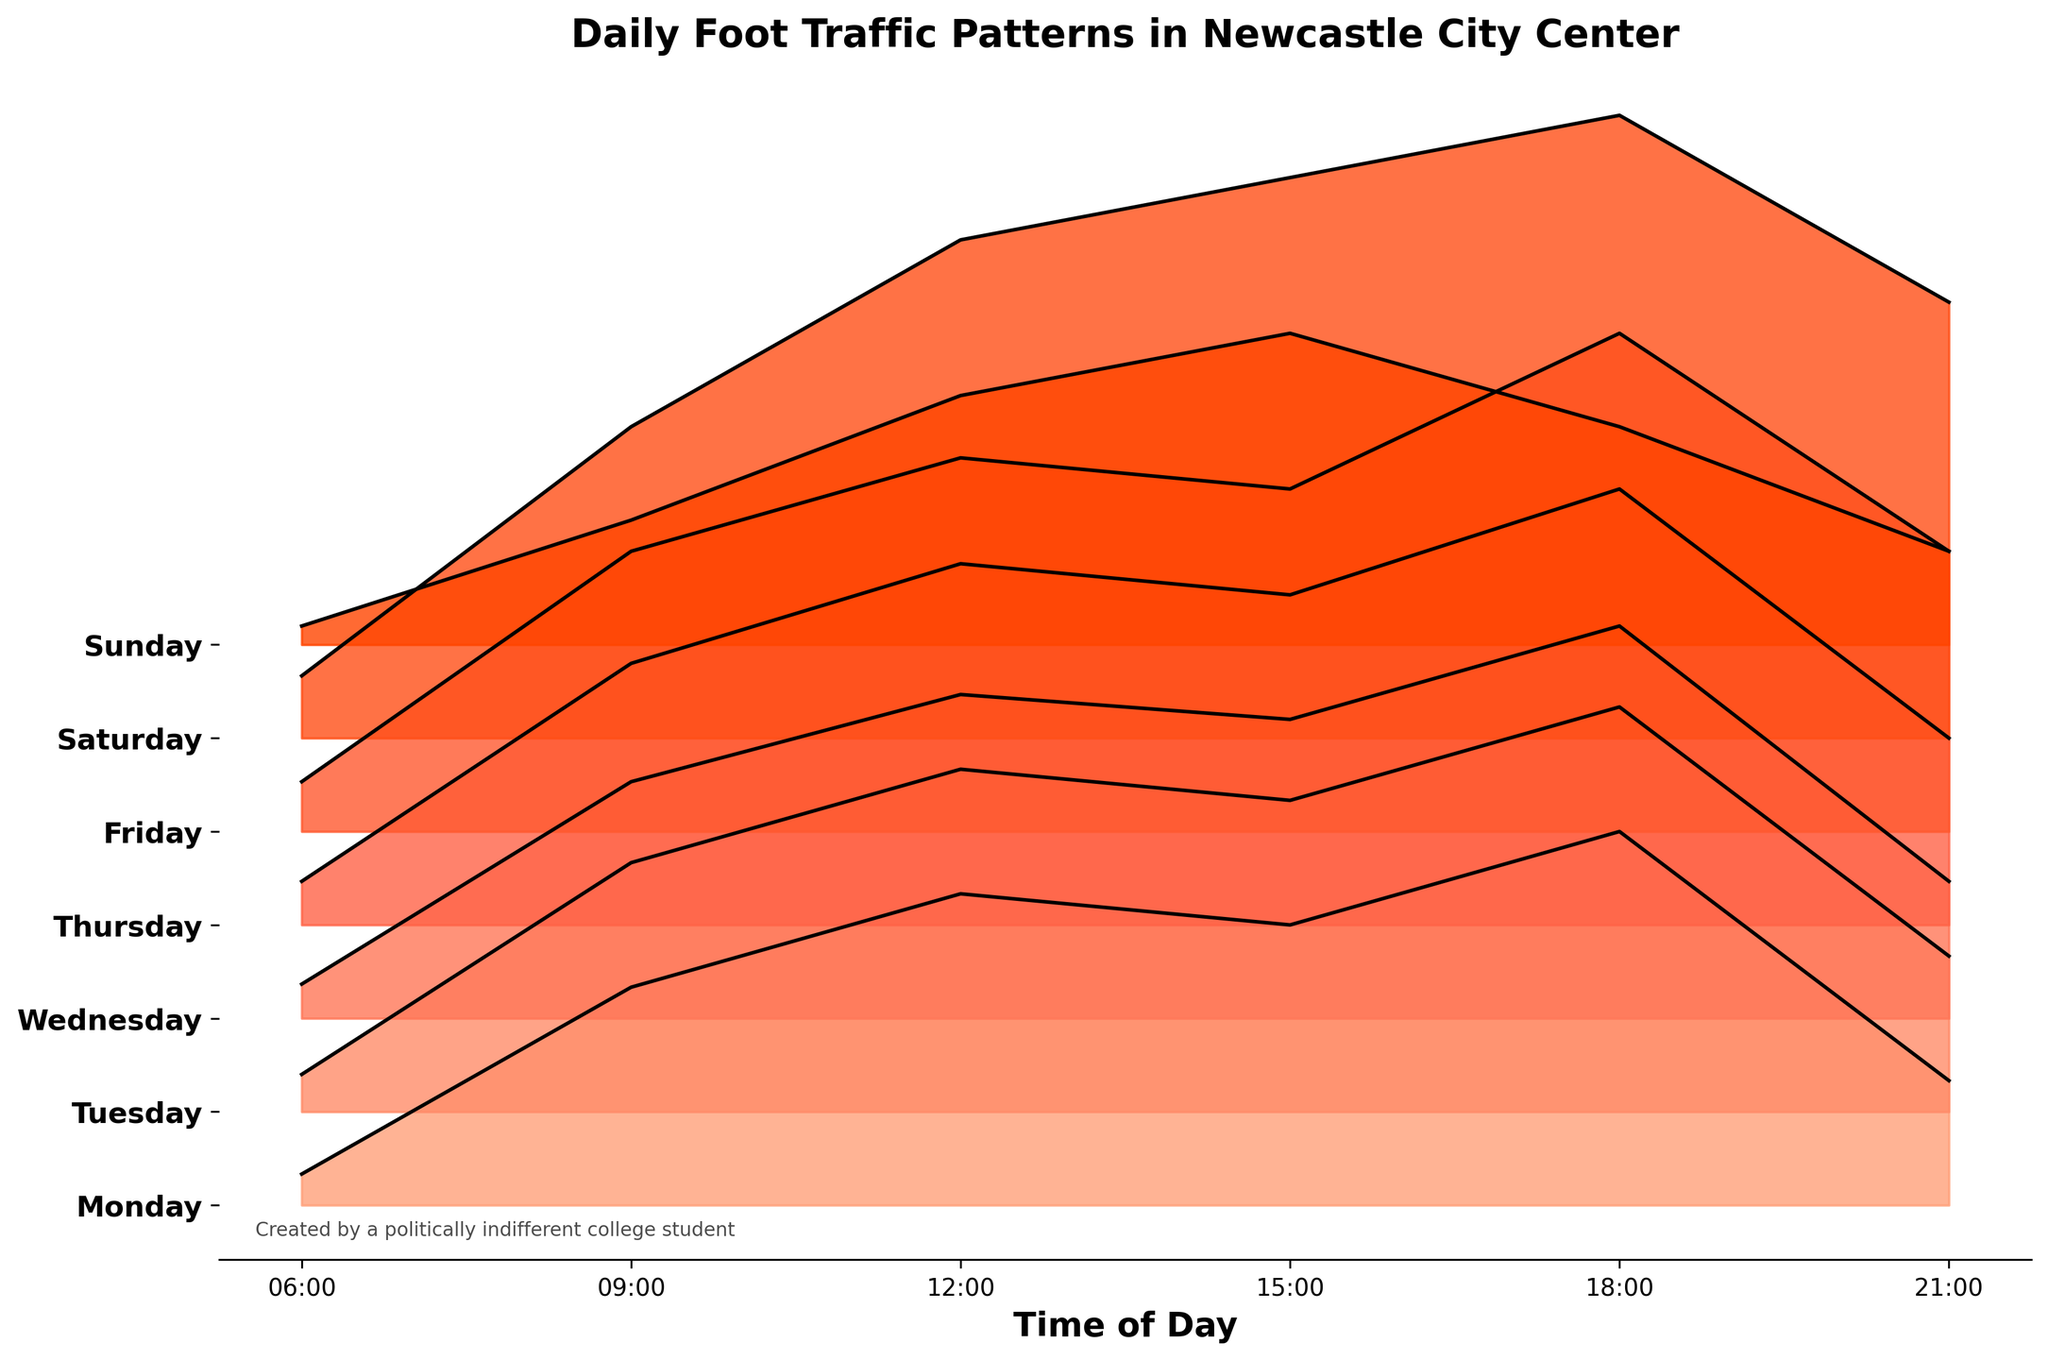What's the peak foot traffic on Saturday? To find the peak foot traffic on Saturday, you look at the data values for Saturday and identify the highest one, which is 1000 at 18:00.
Answer: 1000 Which day has the lowest foot traffic at 6:00? Compare the foot traffic values at 6:00 for each day and find the day with the lowest value, which is Sunday with 30.
Answer: Sunday What times have the highest foot traffic overall in the week? Check the peak values for foot traffic across all days and identify that the highest values occur on Saturday at 18:00 and 15:00 with 1000 and 900 respectively. So, 18:00 has the highest.
Answer: 18:00 How does the foot traffic on Monday at 12:00 compare to the traffic on Tuesday at the same time? Find the foot traffic values for 12:00 on both Monday (500) and Tuesday (550). Since 550 is greater than 500, Tuesday has more foot traffic at that time.
Answer: Tuesday What day generally has the highest foot traffic throughout the day? Summarize the daily patterns and observe that Saturday consistently shows higher foot traffic values compared to the other days, peaking at 1000 at 18:00.
Answer: Saturday Is the foot traffic at 9:00 generally increasing from Monday to Friday? Compare the foot traffic values at 9:00 for Monday (350), Tuesday (400), Wednesday (380), Thursday (420), and Friday (450). Overall, there is a general upward trend.
Answer: Yes For which day is the difference between peak and lowest foot traffic the largest? Find the difference between peak and lowest foot traffic for each day, e.g., Saturday (1000 - 100 = 900) shows the largest difference.
Answer: Saturday Which day has the most consistent foot traffic? Examine the range of foot traffic values for each day. Monday ranges from 50 to 600, Tuesday from 60 to 650, and so on. Sunday ranges from 30 to 500, which is a narrower range compared to others, suggesting more consistency.
Answer: Sunday What's the combined foot traffic at 18:00 on Wednesday and Friday? Add the foot traffic values at 18:00 for Wednesday (630) and Friday (800). So, the combined total is 630 + 800 = 1430.
Answer: 1430 